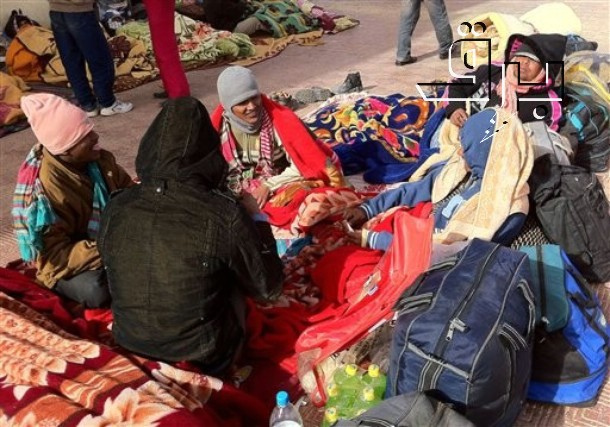Can you delve into the possible backstory of these individuals in the image? Considering their environment and attire, these individuals could be travelers or perhaps people experiencing temporary displacement or homelessness. The assortment of personal items and the make-shift camp suggest that they may be spending significant time outdoors. Despite their circumstances, the way they are gathered, sharing warmth and conversation, suggests a close bond forged through shared experiences and mutual support. It’s possible that they come from different backgrounds but have found common ground and support in each other while navigating their current situation. 